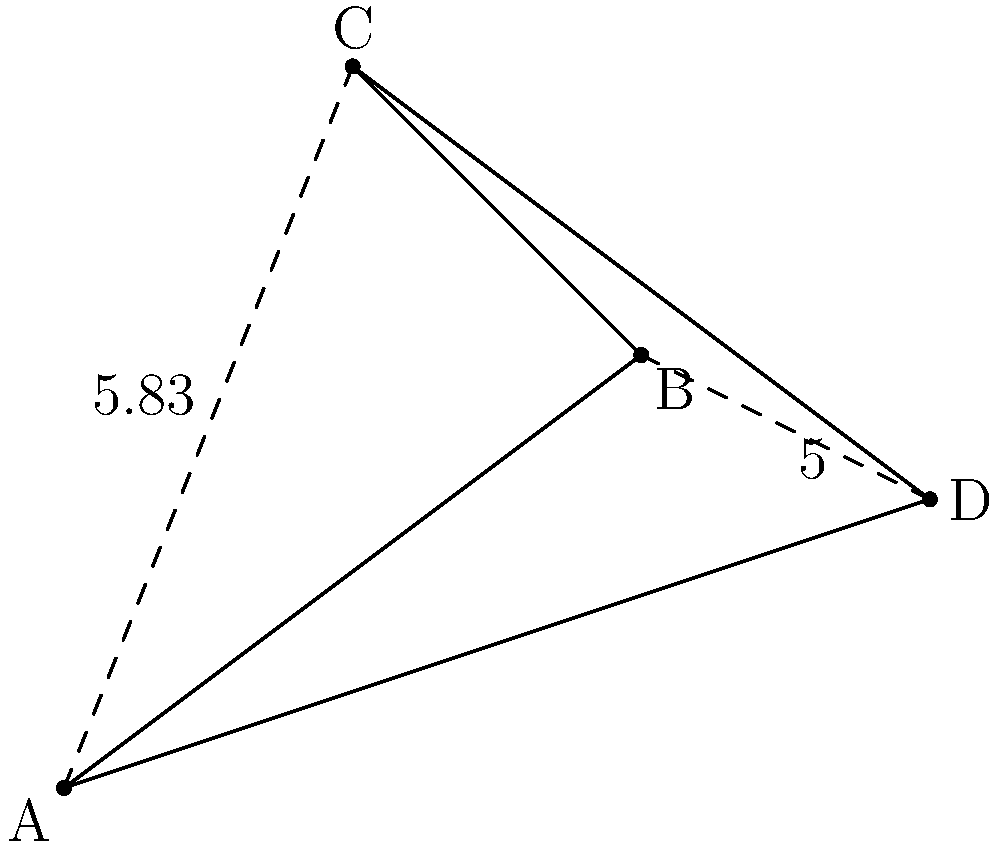In a rural area, four healthcare centers (A, B, C, and D) are located as shown in the diagram. To optimize resource distribution, you need to find the shortest path that connects all four centers. Given that AC = 5.83 units and BD = 5 units, what is the difference in length between the path ABCD and the path ACBD? To solve this problem, we need to compare the lengths of paths ABCD and ACBD:

1. Calculate the length of path ABCD:
   $$L_{ABCD} = AB + BC + CD$$

2. Calculate the length of path ACBD:
   $$L_{ACBD} = AC + CB + BD$$

3. The difference between these paths will be:
   $$\text{Difference} = |L_{ABCD} - L_{ACBD}|$$

4. We don't have all the individual side lengths, but we know:
   AC = 5.83 units
   BD = 5 units

5. In a quadrilateral, the sum of any two sides is always greater than the diagonal that connects their endpoints. Therefore:
   $$AB + CD > AC$$
   $$AB + CD > 5.83$$

   $$BC + AD > BD$$
   $$BC + AD > 5$$

6. This means that:
   $$L_{ABCD} = AB + BC + CD > AC + BD = 5.83 + 5 = 10.83$$

7. And:
   $$L_{ACBD} = AC + CB + BD = 5.83 + CB + 5$$

8. Since CB is a positive length, $L_{ACBD}$ will always be greater than 10.83 units.

9. Therefore, $L_{ABCD}$ will always be shorter than $L_{ACBD}$.

10. The exact difference cannot be calculated without knowing all side lengths, but we can conclude that path ABCD is shorter than path ACBD.
Answer: Path ABCD is shorter than path ACBD. 